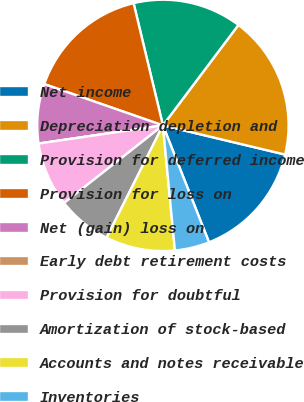<chart> <loc_0><loc_0><loc_500><loc_500><pie_chart><fcel>Net income<fcel>Depreciation depletion and<fcel>Provision for deferred income<fcel>Provision for loss on<fcel>Net (gain) loss on<fcel>Early debt retirement costs<fcel>Provision for doubtful<fcel>Amortization of stock-based<fcel>Accounts and notes receivable<fcel>Inventories<nl><fcel>15.29%<fcel>18.47%<fcel>14.01%<fcel>15.92%<fcel>7.64%<fcel>0.0%<fcel>8.28%<fcel>7.01%<fcel>8.92%<fcel>4.46%<nl></chart> 